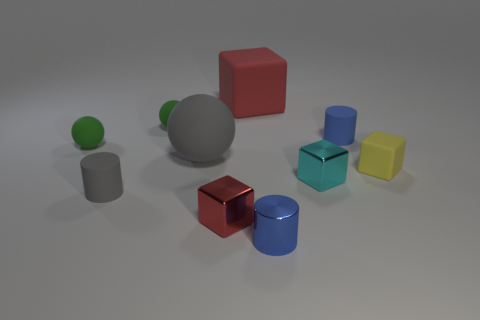Subtract all tiny cyan metal cubes. How many cubes are left? 3 Subtract all gray blocks. Subtract all purple cylinders. How many blocks are left? 4 Subtract all cubes. How many objects are left? 6 Subtract 0 blue spheres. How many objects are left? 10 Subtract all green rubber balls. Subtract all yellow objects. How many objects are left? 7 Add 1 shiny cylinders. How many shiny cylinders are left? 2 Add 9 large green rubber cubes. How many large green rubber cubes exist? 9 